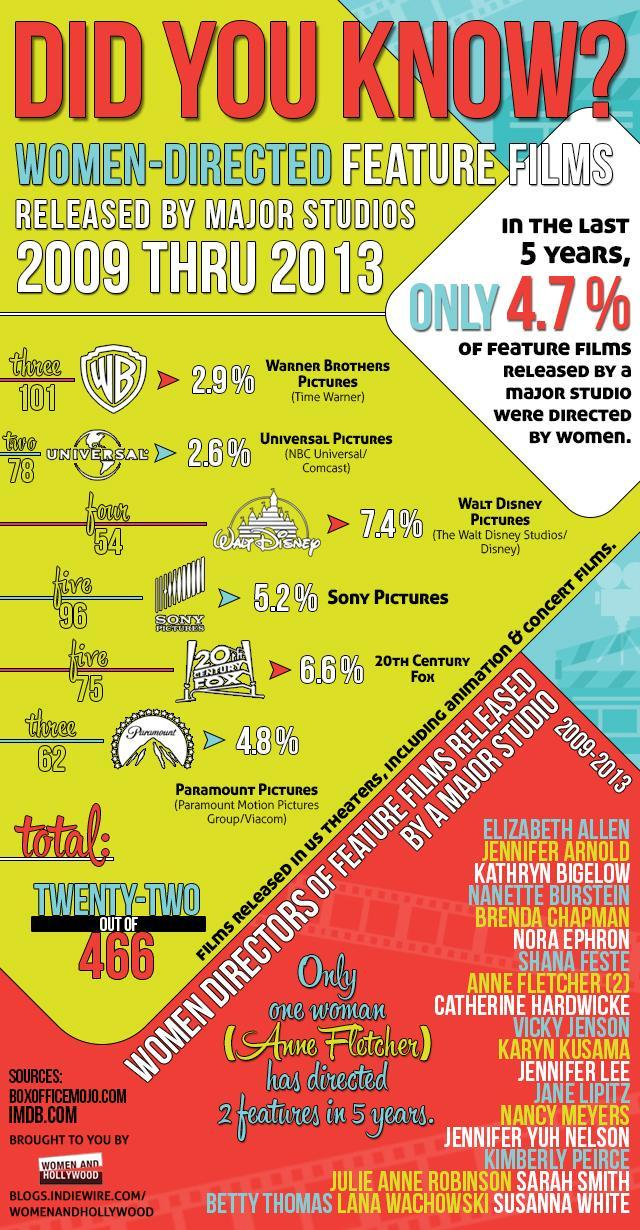What percentage of feature films released by a major studio in the last five years were not directed by women?
Answer the question with a short phrase. 95.3% 